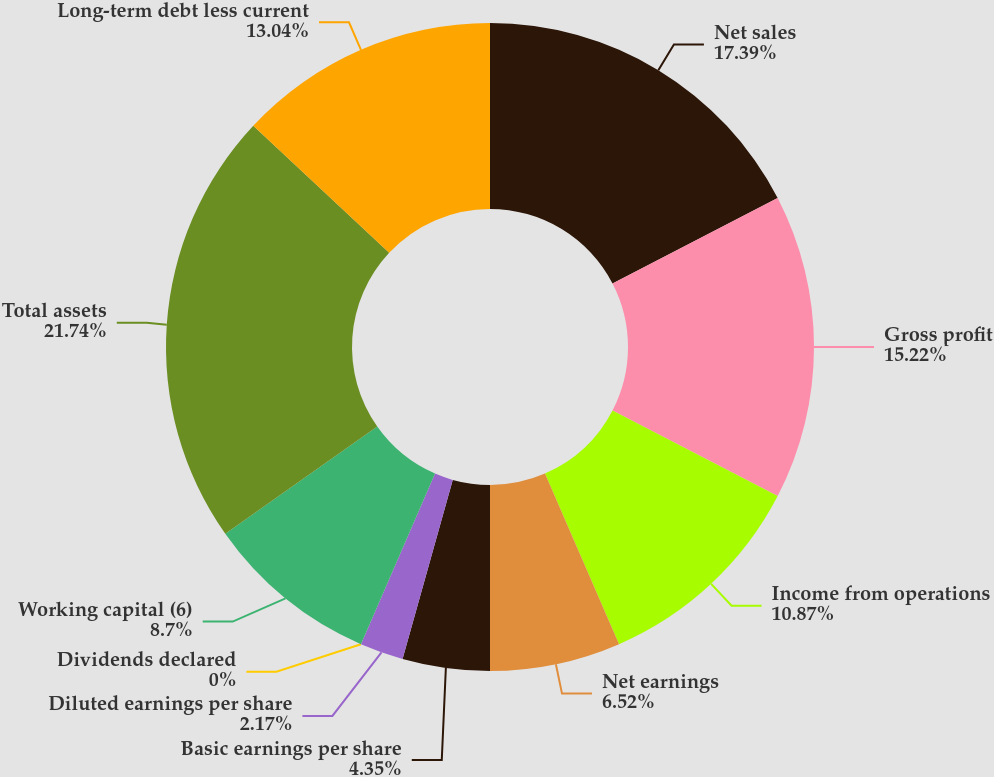Convert chart. <chart><loc_0><loc_0><loc_500><loc_500><pie_chart><fcel>Net sales<fcel>Gross profit<fcel>Income from operations<fcel>Net earnings<fcel>Basic earnings per share<fcel>Diluted earnings per share<fcel>Dividends declared<fcel>Working capital (6)<fcel>Total assets<fcel>Long-term debt less current<nl><fcel>17.39%<fcel>15.22%<fcel>10.87%<fcel>6.52%<fcel>4.35%<fcel>2.17%<fcel>0.0%<fcel>8.7%<fcel>21.74%<fcel>13.04%<nl></chart> 